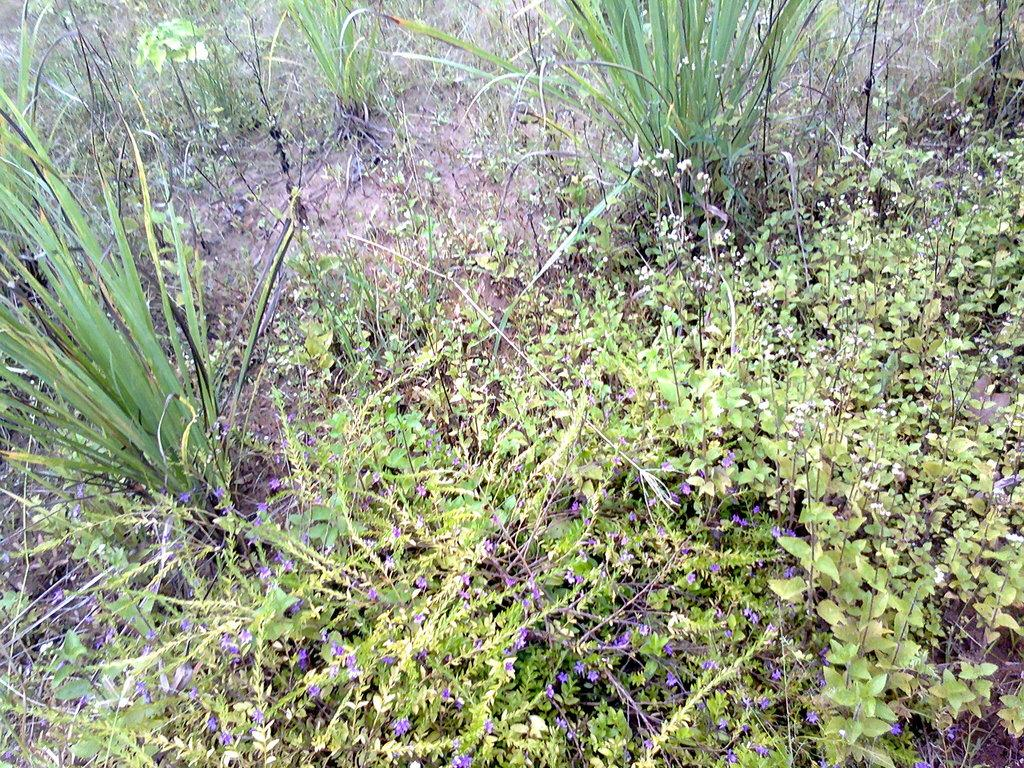What celestial bodies can be seen on the surface in the image? There are planets visible on the surface in the image. Can you describe the appearance of the planets? Unfortunately, the image does not provide enough detail to describe the appearance of the planets. Are there any other objects or features visible on the surface in the image? The provided facts do not mention any other objects or features visible on the surface in the image. What type of liquid is being used to celebrate a birth in the image? There is no mention of a birth or any liquid in the image; it only features planets visible on the surface. 